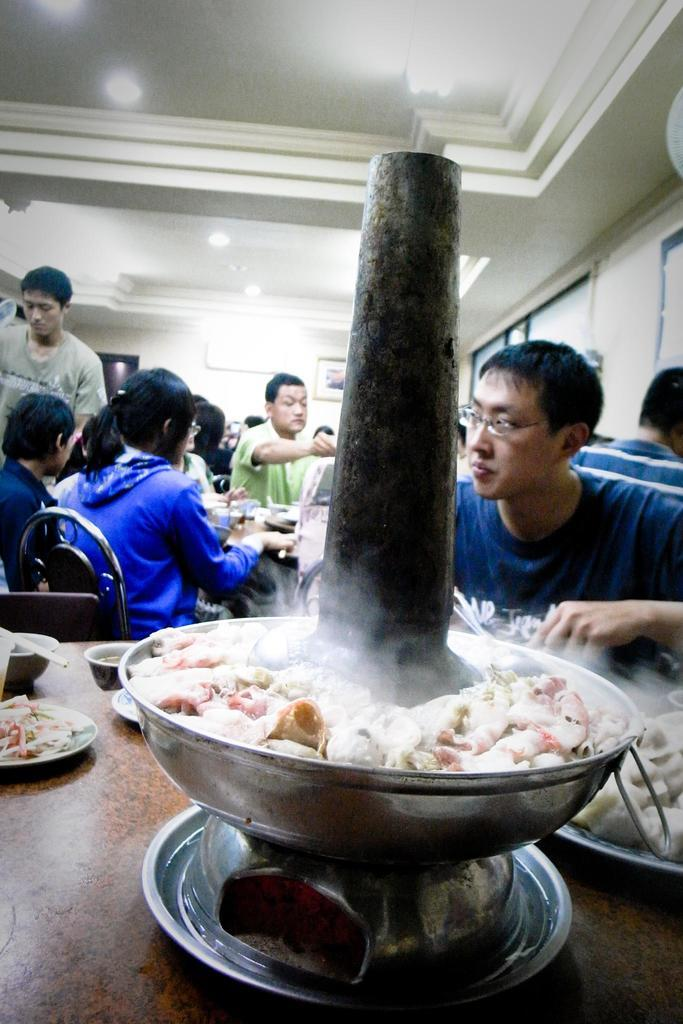What is in the hot bowl that is visible in the image? There is a hot bowl with food items in the image. What are the people in the image doing? The people are sitting and having food on a dining table. What type of lighting is present in the image? There are ceiling lights visible in the image. Can you describe the chicken that is sitting on the stranger's lap in the image? There is no chicken or stranger present in the image. 